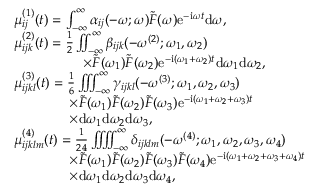<formula> <loc_0><loc_0><loc_500><loc_500>\begin{array} { r l } & { \mu _ { i j } ^ { ( 1 ) } ( t ) = \int _ { - \infty } ^ { \infty } \alpha _ { i j } ( - \omega ; \omega ) \tilde { F } ( \omega ) e ^ { - i \omega t } d \omega , } \\ & { \mu _ { i j k } ^ { ( 2 ) } ( t ) = \frac { 1 } { 2 } \iint _ { - \infty } ^ { \infty } \beta _ { i j k } ( - \omega ^ { ( 2 ) } ; \omega _ { 1 } , \omega _ { 2 } ) } \\ & { \quad \times \tilde { F } ( \omega _ { 1 } ) \tilde { F } ( \omega _ { 2 } ) e ^ { - i ( \omega _ { 1 } + \omega _ { 2 } ) t } d \omega _ { 1 } d \omega _ { 2 } , } \\ & { \mu _ { i j k l } ^ { ( 3 ) } ( t ) = \frac { 1 } { 6 } \iint \, \int _ { - \infty } ^ { \infty } \gamma _ { i j k l } ( - \omega ^ { ( 3 ) } ; \omega _ { 1 } , \omega _ { 2 } , \omega _ { 3 } ) } \\ & { \quad \times \tilde { F } ( \omega _ { 1 } ) \tilde { F } ( \omega _ { 2 } ) \tilde { F } ( \omega _ { 3 } ) e ^ { - i ( \omega _ { 1 } + \omega _ { 2 } + \omega _ { 3 } ) t } } \\ & { \quad \times d \omega _ { 1 } d \omega _ { 2 } d \omega _ { 3 } , } \\ & { \mu _ { i j k l m } ^ { ( 4 ) } ( t ) = \frac { 1 } { 2 4 } \iint \, \iint _ { - \infty } ^ { \infty } \delta _ { i j k l m } ( - \omega ^ { ( 4 ) } ; \omega _ { 1 } , \omega _ { 2 } , \omega _ { 3 } , \omega _ { 4 } ) } \\ & { \quad \times \tilde { F } ( \omega _ { 1 } ) \tilde { F } ( \omega _ { 2 } ) \tilde { F } ( \omega _ { 3 } ) \tilde { F } ( \omega _ { 4 } ) e ^ { - i ( \omega _ { 1 } + \omega _ { 2 } + \omega _ { 3 } + \omega _ { 4 } ) t } } \\ & { \quad \times d \omega _ { 1 } d \omega _ { 2 } d \omega _ { 3 } d \omega _ { 4 } , } \end{array}</formula> 